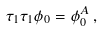<formula> <loc_0><loc_0><loc_500><loc_500>\tau _ { 1 } \tau _ { 1 } \phi _ { 0 } = \phi ^ { A } _ { 0 } \, ,</formula> 